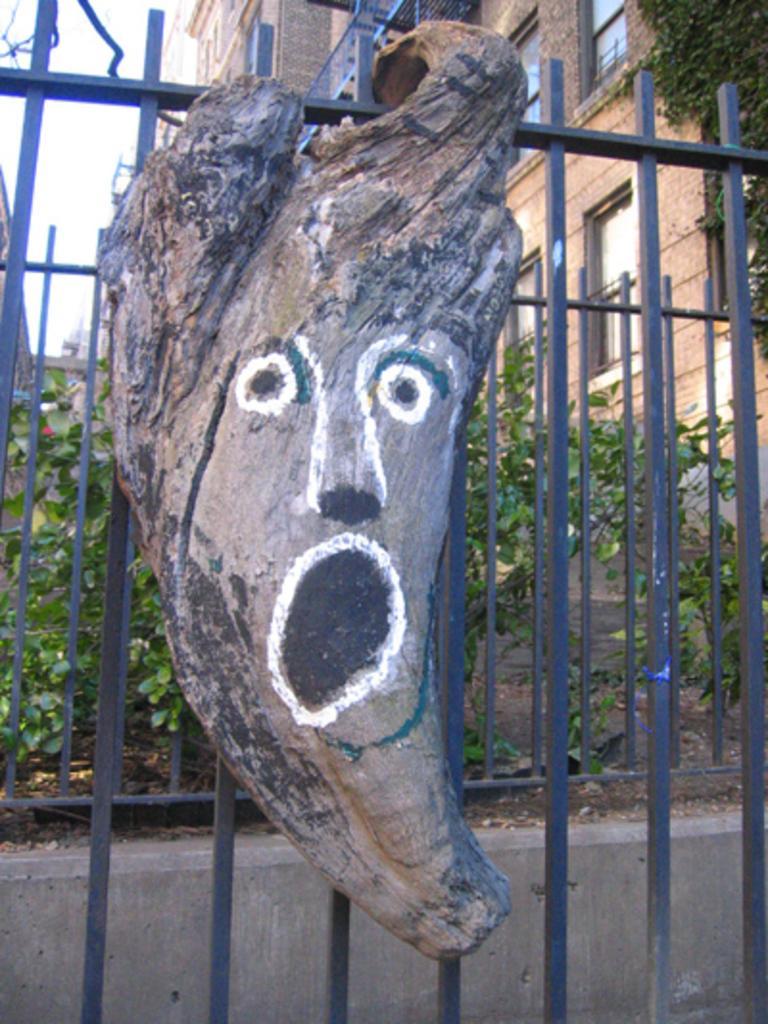In one or two sentences, can you explain what this image depicts? In this image there is a painting on the wooden trunk which is hanged to a metal fence. In the background of the image there are buildings, plants, trees and sky. 